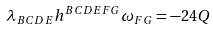Convert formula to latex. <formula><loc_0><loc_0><loc_500><loc_500>\lambda _ { B C D E } h ^ { B C D E F G } \omega _ { F G } = - 2 4 Q</formula> 